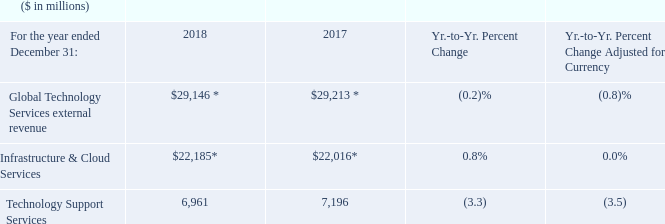* Recast to reflect segment changes.
Global Technology Services revenue decreased 0.2 percent as reported (1 percent adjusted for currency) in 2018 compared to the prior year, with Infrastructure & Cloud Services up 0.8 percent as reported (flat adjusted for currency) offset by a decline in Technology Support Services.
In Infrastructure & Cloud Services, the business focused on prioritizing the portfolio to deliver high-value solutions to bring productivity to clients and allow for expanding workloads, while it exited some lower-value offerings. Technology Support Services was impacted by the hardware product cycle dynamics in 2018 but grew its multivendor services offerings. Within GTS, cloud revenue of $8.0 billion grew 22 percent as reported and 21 percent adjusted for currency compared to the prior year.
What was the focus area for business in Infrastructure & Cloud Services  In infrastructure & cloud services, the business focused on prioritizing the portfolio to deliver high-value solutions to bring productivity to clients and allow for expanding workloads, while it exited some lower-value offerings. What impacted the Technology Support Services in 2018? Technology support services was impacted by the hardware product cycle dynamics in 2018. How much did the cloud revenue grew within GTS? Within gts, cloud revenue of $8.0 billion grew 22 percent as reported and 21 percent adjusted for currency compared to the prior year. What is the increase/ (decrease) in Global Technology Services external revenue from 2017 to 2018
Answer scale should be: million. 29,146-29,213 
Answer: -67. What is the average of Global Technology Services external revenue for the year 2018 and 2017
Answer scale should be: million. (29,146+29,213) / 2
Answer: 29179.5. What is the increase/ (decrease) in Technology Support Services from 2017 to 2018
Answer scale should be: million. 6,961-7,196
Answer: -235. 